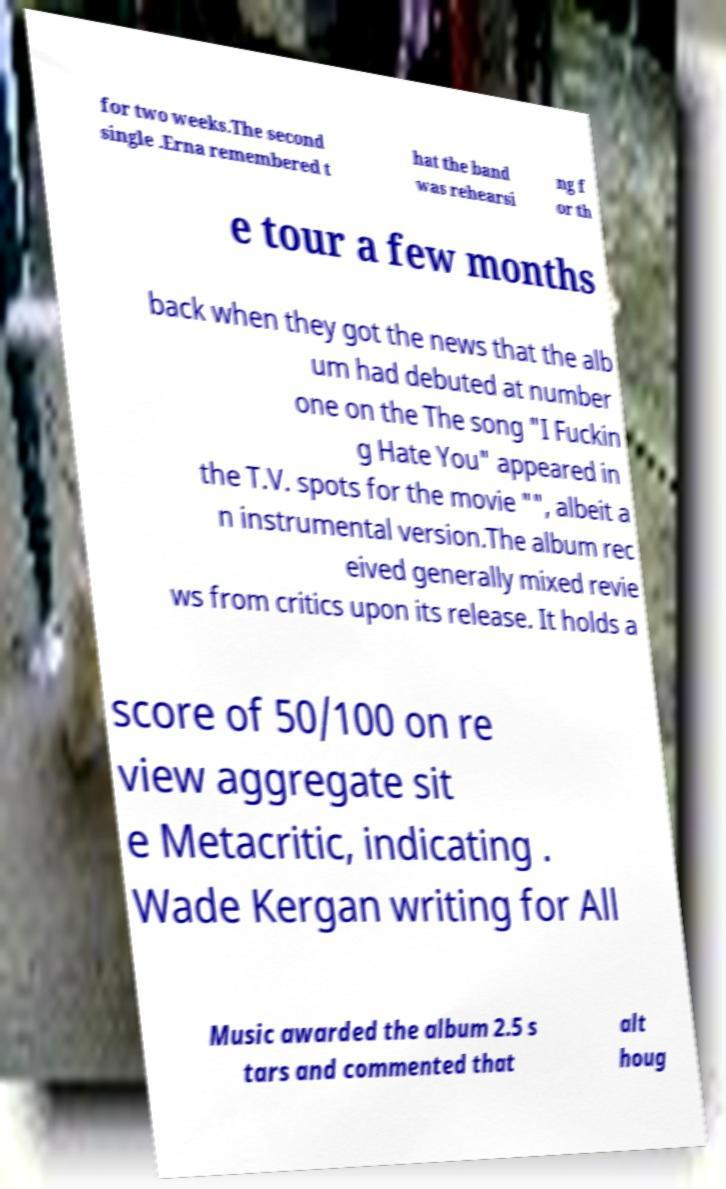Can you accurately transcribe the text from the provided image for me? for two weeks.The second single .Erna remembered t hat the band was rehearsi ng f or th e tour a few months back when they got the news that the alb um had debuted at number one on the The song "I Fuckin g Hate You" appeared in the T.V. spots for the movie "", albeit a n instrumental version.The album rec eived generally mixed revie ws from critics upon its release. It holds a score of 50/100 on re view aggregate sit e Metacritic, indicating . Wade Kergan writing for All Music awarded the album 2.5 s tars and commented that alt houg 